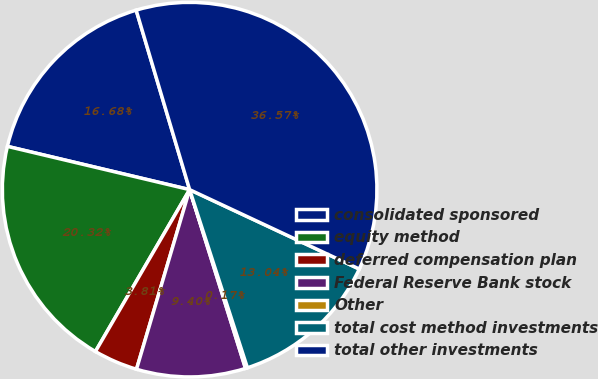<chart> <loc_0><loc_0><loc_500><loc_500><pie_chart><fcel>consolidated sponsored<fcel>equity method<fcel>deferred compensation plan<fcel>Federal Reserve Bank stock<fcel>Other<fcel>total cost method investments<fcel>total other investments<nl><fcel>16.68%<fcel>20.32%<fcel>3.81%<fcel>9.4%<fcel>0.17%<fcel>13.04%<fcel>36.57%<nl></chart> 